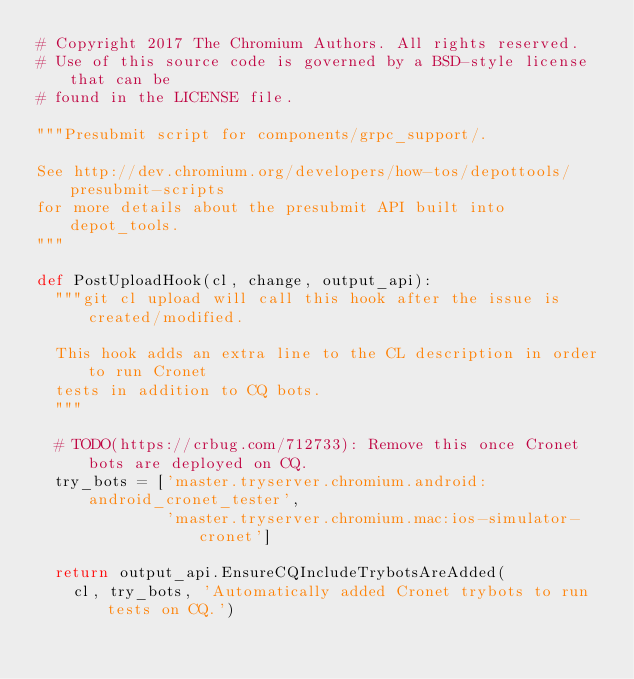<code> <loc_0><loc_0><loc_500><loc_500><_Python_># Copyright 2017 The Chromium Authors. All rights reserved.
# Use of this source code is governed by a BSD-style license that can be
# found in the LICENSE file.

"""Presubmit script for components/grpc_support/.

See http://dev.chromium.org/developers/how-tos/depottools/presubmit-scripts
for more details about the presubmit API built into depot_tools.
"""

def PostUploadHook(cl, change, output_api):
  """git cl upload will call this hook after the issue is created/modified.

  This hook adds an extra line to the CL description in order to run Cronet
  tests in addition to CQ bots.
  """

  # TODO(https://crbug.com/712733): Remove this once Cronet bots are deployed on CQ.
  try_bots = ['master.tryserver.chromium.android:android_cronet_tester',
              'master.tryserver.chromium.mac:ios-simulator-cronet']

  return output_api.EnsureCQIncludeTrybotsAreAdded(
    cl, try_bots, 'Automatically added Cronet trybots to run tests on CQ.')
</code> 